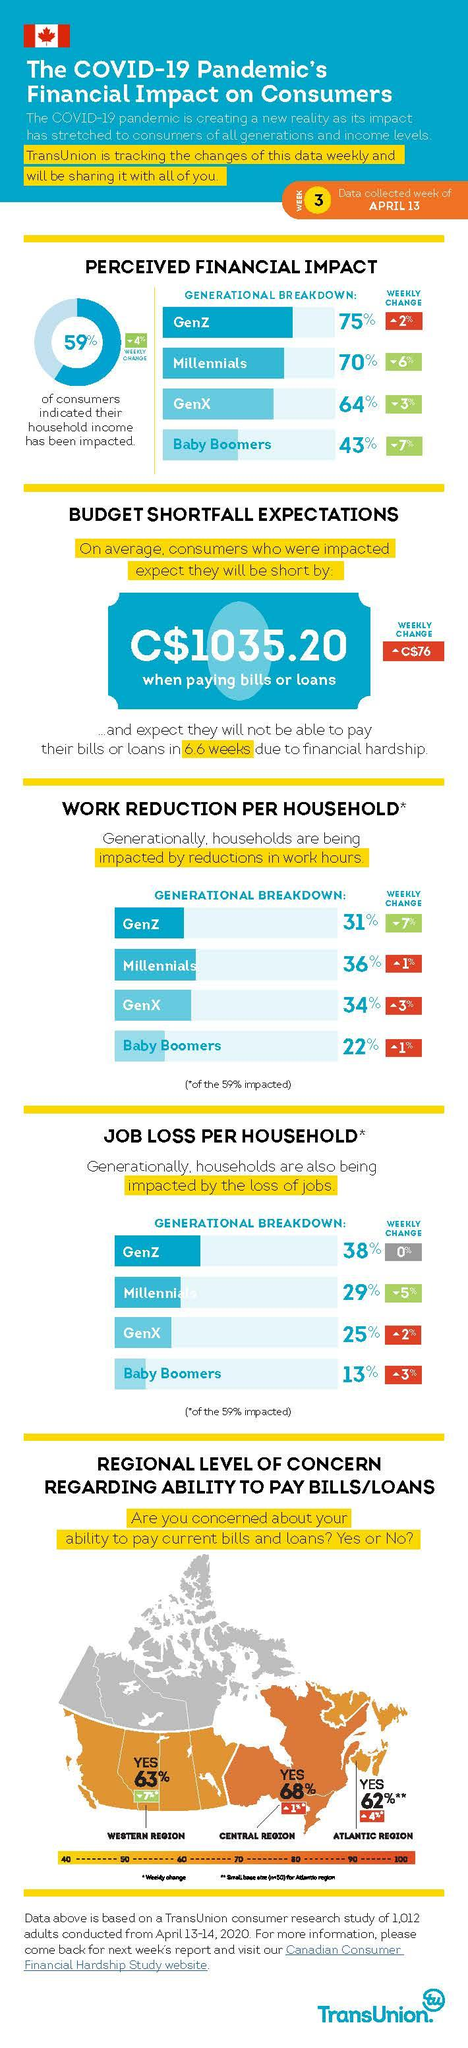Draw attention to some important aspects in this diagram. Gen X individuals make up the second highest percentage of those impacted by reduced work hours, according to research. According to the data, the lowest percentage of people reported feeling the financial impact of the pandemic among Baby Boomers. Millennial consumers are most significantly affected by reductions in work hours due to the unique combination of factors that define their generation. Gen Z has been the generation most affected by job loss. The Central region is known for having residents who are most concerned about bills and loan payments. 